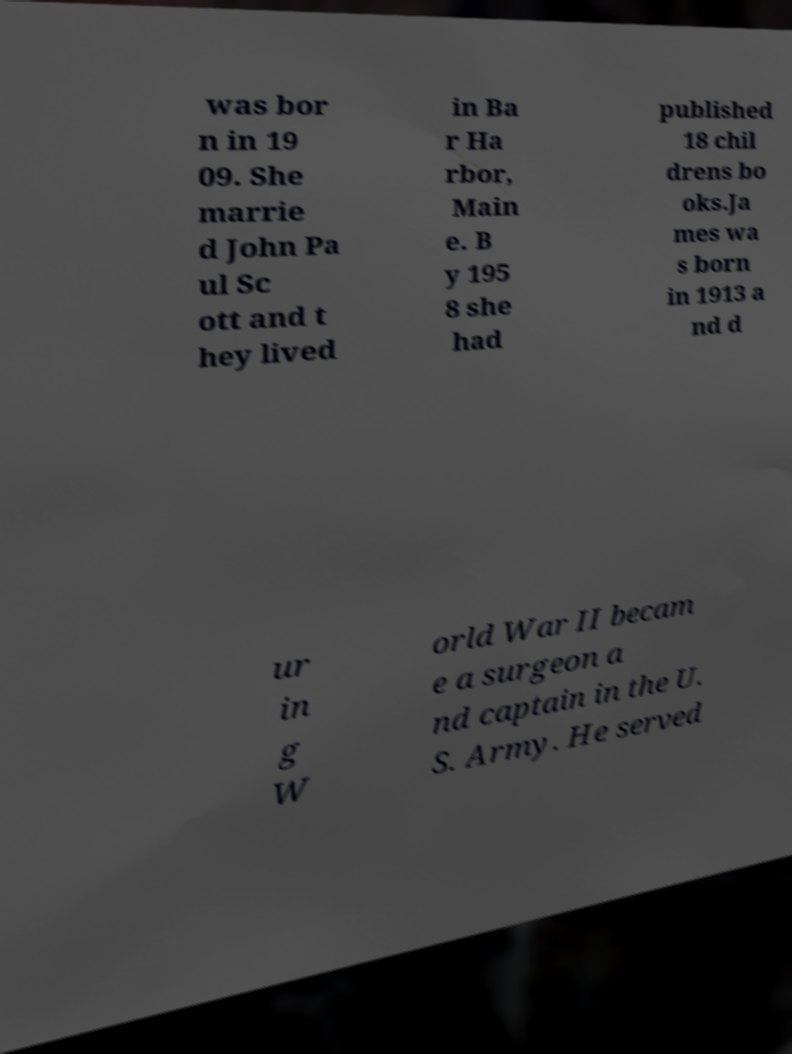Could you assist in decoding the text presented in this image and type it out clearly? was bor n in 19 09. She marrie d John Pa ul Sc ott and t hey lived in Ba r Ha rbor, Main e. B y 195 8 she had published 18 chil drens bo oks.Ja mes wa s born in 1913 a nd d ur in g W orld War II becam e a surgeon a nd captain in the U. S. Army. He served 